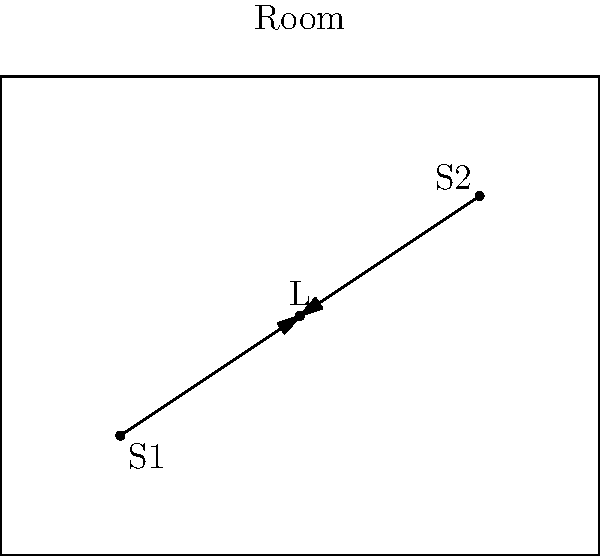In a rectangular room, two speakers (S1 and S2) are positioned at coordinates (1,1) and (4,3) respectively. A listener (L) is located at (2.5,2). Using vector addition and subtraction, calculate the optimal position for a third speaker to create an equilateral triangle with the existing speakers and the listener at its center. Express your answer as coordinates (x,y). Let's approach this step-by-step:

1) First, we need to find the vectors from the listener to each speaker:
   $\vec{LS1} = (1-2.5, 1-2) = (-1.5, -1)$
   $\vec{LS2} = (4-2.5, 3-2) = (1.5, 1)$

2) To create an equilateral triangle, the third speaker (S3) should be positioned such that $\vec{LS3}$ is equal in magnitude but opposite in direction to $\vec{LS1} + \vec{LS2}$:

   $\vec{LS3} = -(\vec{LS1} + \vec{LS2})$

3) Calculate $\vec{LS1} + \vec{LS2}$:
   $(-1.5, -1) + (1.5, 1) = (0, 0)$

4) Therefore, $\vec{LS3} = -(0, 0) = (0, 0)$

5) This means S3 should be positioned at the same point as the listener.

6) To find the coordinates of S3, we add $\vec{LS3}$ to the coordinates of L:
   $S3 = (2.5, 2) + (0, 0) = (2.5, 2)$

Thus, the optimal position for the third speaker is (2.5, 2), which coincides with the listener's position.
Answer: (2.5, 2) 